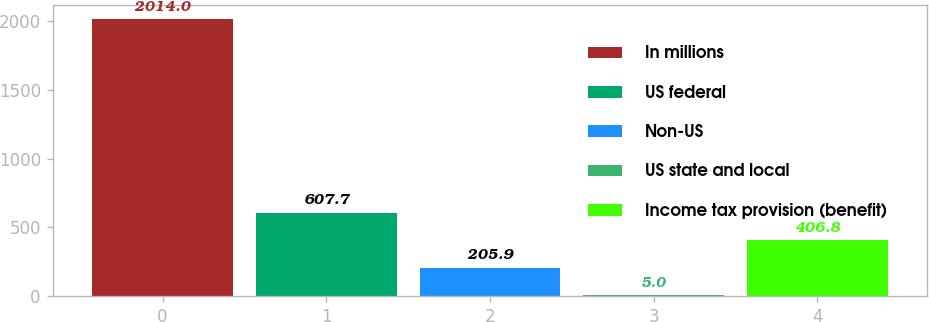<chart> <loc_0><loc_0><loc_500><loc_500><bar_chart><fcel>In millions<fcel>US federal<fcel>Non-US<fcel>US state and local<fcel>Income tax provision (benefit)<nl><fcel>2014<fcel>607.7<fcel>205.9<fcel>5<fcel>406.8<nl></chart> 